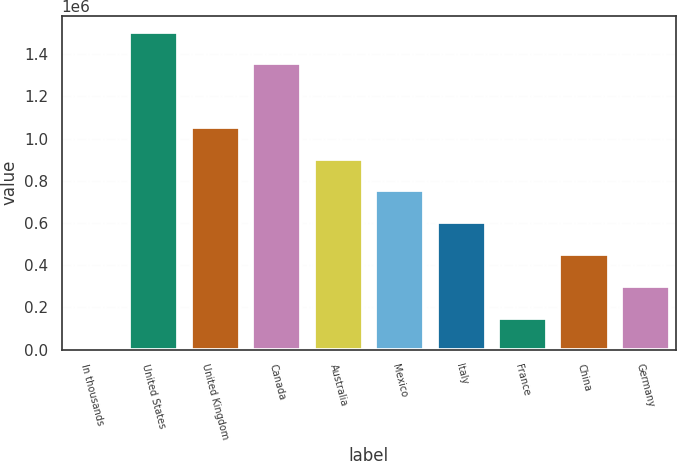Convert chart. <chart><loc_0><loc_0><loc_500><loc_500><bar_chart><fcel>In thousands<fcel>United States<fcel>United Kingdom<fcel>Canada<fcel>Australia<fcel>Mexico<fcel>Italy<fcel>France<fcel>China<fcel>Germany<nl><fcel>2010<fcel>1.50701e+06<fcel>1.05551e+06<fcel>1.35651e+06<fcel>905011<fcel>754511<fcel>604011<fcel>152510<fcel>453511<fcel>303010<nl></chart> 